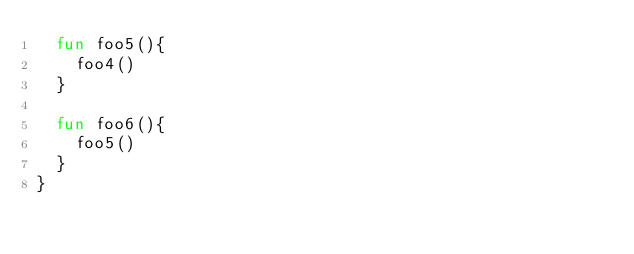Convert code to text. <code><loc_0><loc_0><loc_500><loc_500><_Kotlin_>  fun foo5(){
    foo4()
  }

  fun foo6(){
    foo5()
  }
}</code> 